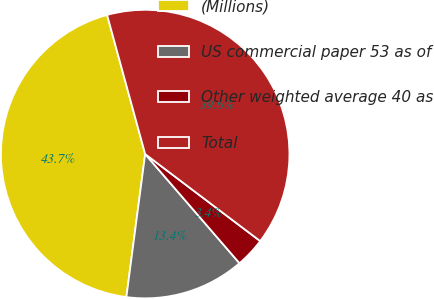<chart> <loc_0><loc_0><loc_500><loc_500><pie_chart><fcel>(Millions)<fcel>US commercial paper 53 as of<fcel>Other weighted average 40 as<fcel>Total<nl><fcel>43.67%<fcel>13.42%<fcel>3.35%<fcel>39.56%<nl></chart> 